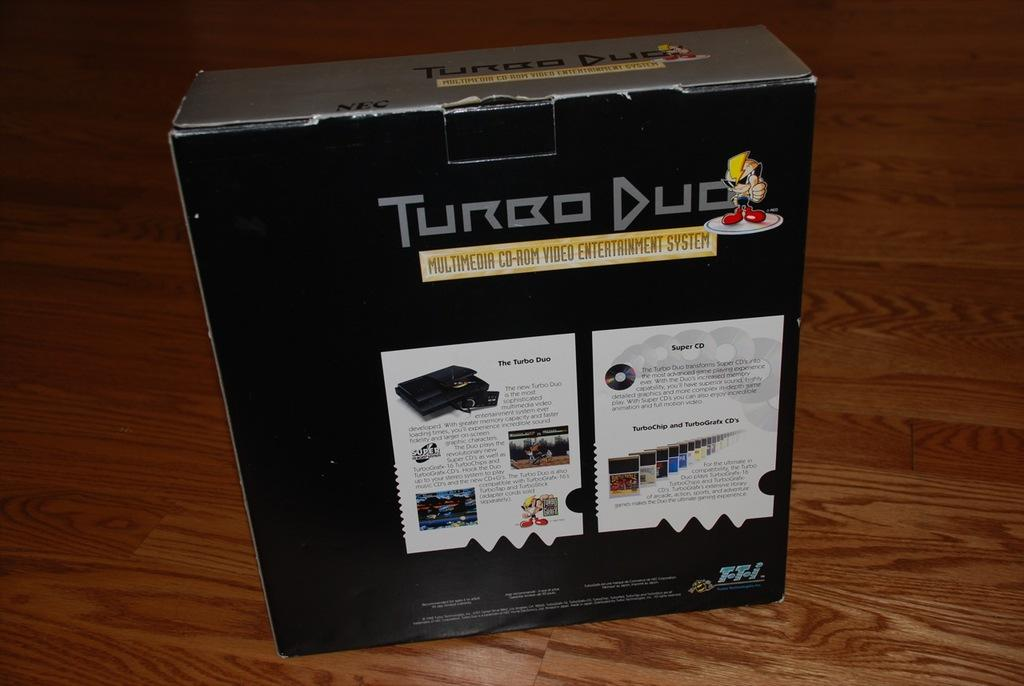<image>
Present a compact description of the photo's key features. Large black box with the name Turbo Duo on the top. 